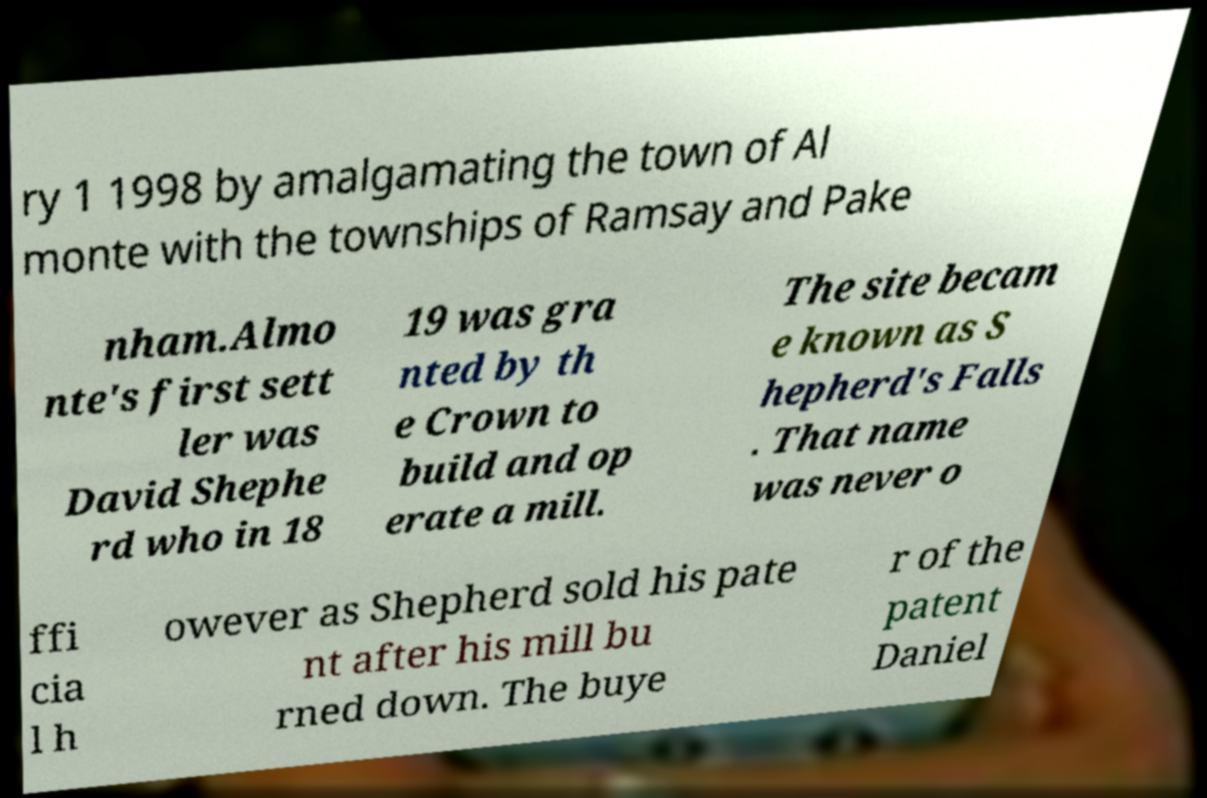I need the written content from this picture converted into text. Can you do that? ry 1 1998 by amalgamating the town of Al monte with the townships of Ramsay and Pake nham.Almo nte's first sett ler was David Shephe rd who in 18 19 was gra nted by th e Crown to build and op erate a mill. The site becam e known as S hepherd's Falls . That name was never o ffi cia l h owever as Shepherd sold his pate nt after his mill bu rned down. The buye r of the patent Daniel 